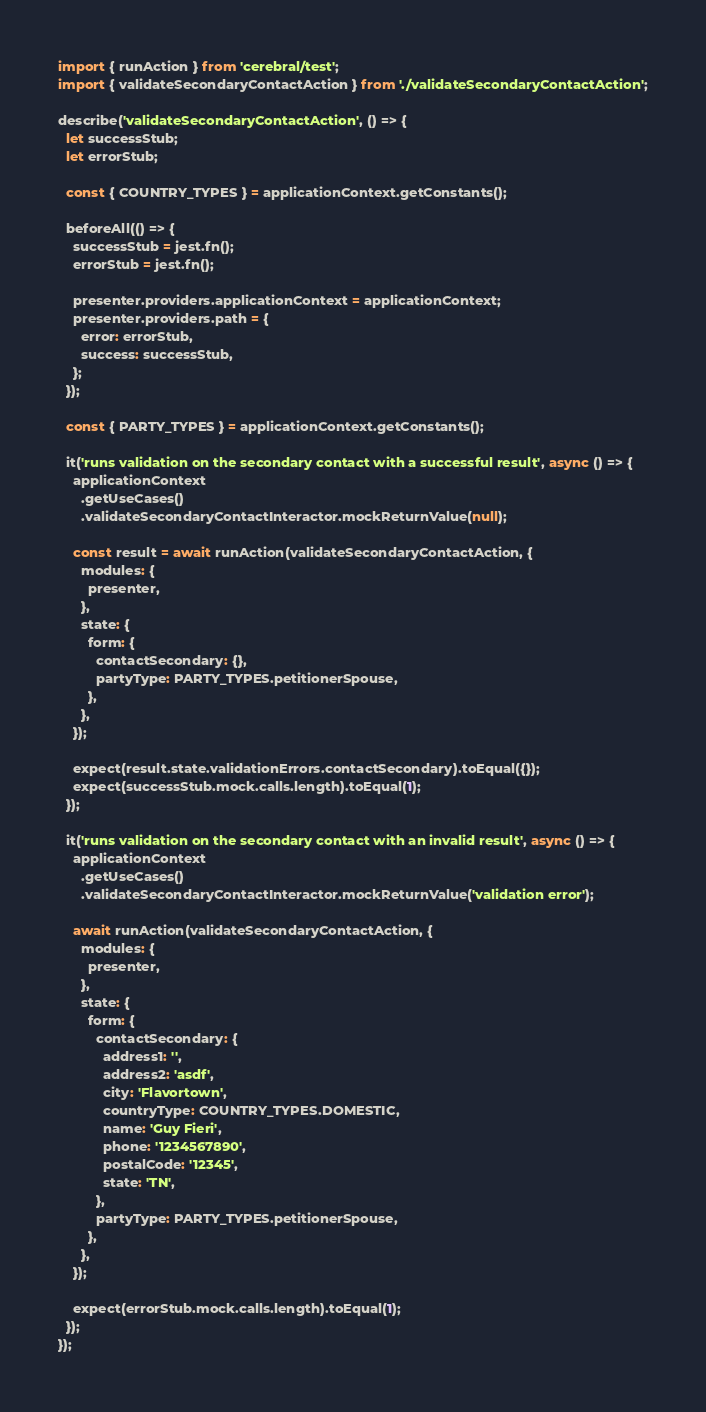Convert code to text. <code><loc_0><loc_0><loc_500><loc_500><_JavaScript_>import { runAction } from 'cerebral/test';
import { validateSecondaryContactAction } from './validateSecondaryContactAction';

describe('validateSecondaryContactAction', () => {
  let successStub;
  let errorStub;

  const { COUNTRY_TYPES } = applicationContext.getConstants();

  beforeAll(() => {
    successStub = jest.fn();
    errorStub = jest.fn();

    presenter.providers.applicationContext = applicationContext;
    presenter.providers.path = {
      error: errorStub,
      success: successStub,
    };
  });

  const { PARTY_TYPES } = applicationContext.getConstants();

  it('runs validation on the secondary contact with a successful result', async () => {
    applicationContext
      .getUseCases()
      .validateSecondaryContactInteractor.mockReturnValue(null);

    const result = await runAction(validateSecondaryContactAction, {
      modules: {
        presenter,
      },
      state: {
        form: {
          contactSecondary: {},
          partyType: PARTY_TYPES.petitionerSpouse,
        },
      },
    });

    expect(result.state.validationErrors.contactSecondary).toEqual({});
    expect(successStub.mock.calls.length).toEqual(1);
  });

  it('runs validation on the secondary contact with an invalid result', async () => {
    applicationContext
      .getUseCases()
      .validateSecondaryContactInteractor.mockReturnValue('validation error');

    await runAction(validateSecondaryContactAction, {
      modules: {
        presenter,
      },
      state: {
        form: {
          contactSecondary: {
            address1: '',
            address2: 'asdf',
            city: 'Flavortown',
            countryType: COUNTRY_TYPES.DOMESTIC,
            name: 'Guy Fieri',
            phone: '1234567890',
            postalCode: '12345',
            state: 'TN',
          },
          partyType: PARTY_TYPES.petitionerSpouse,
        },
      },
    });

    expect(errorStub.mock.calls.length).toEqual(1);
  });
});
</code> 